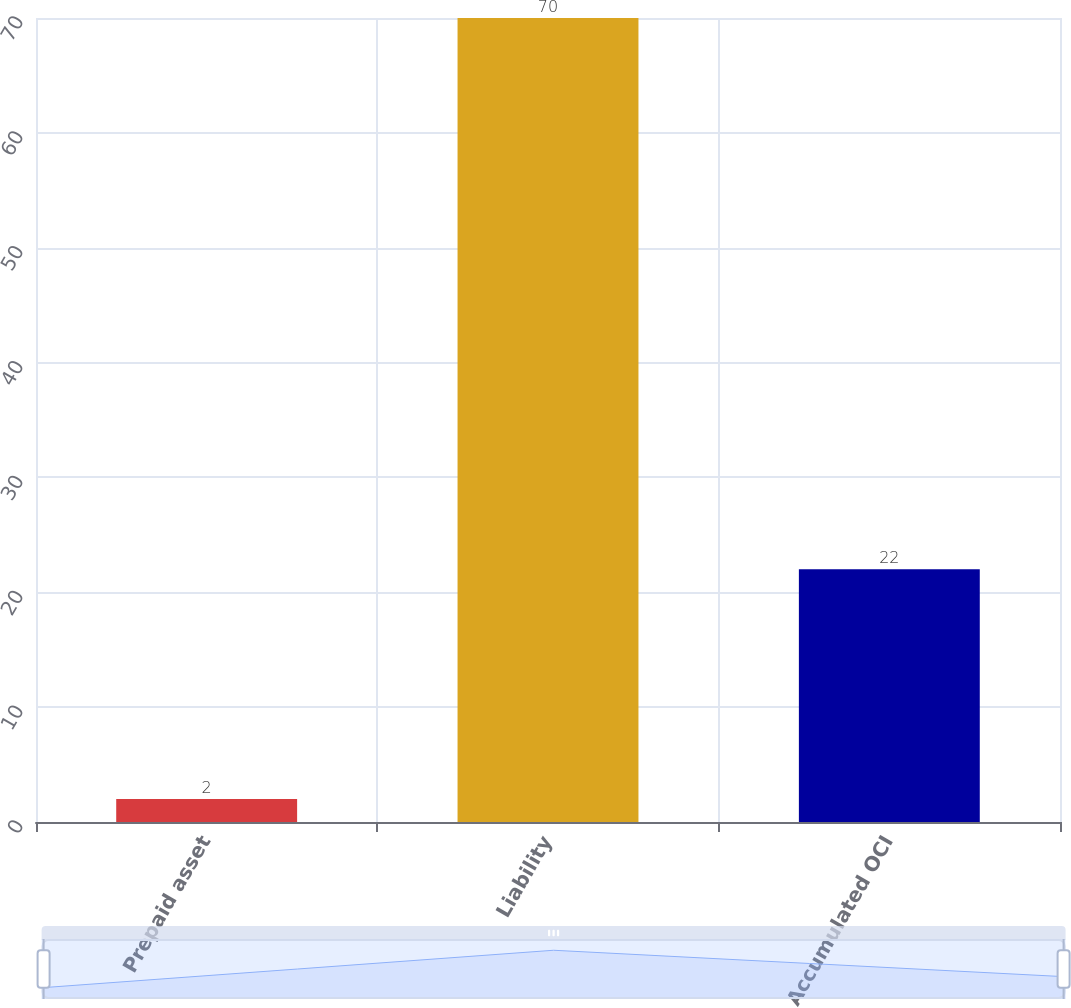Convert chart. <chart><loc_0><loc_0><loc_500><loc_500><bar_chart><fcel>Prepaid asset<fcel>Liability<fcel>Accumulated OCI<nl><fcel>2<fcel>70<fcel>22<nl></chart> 